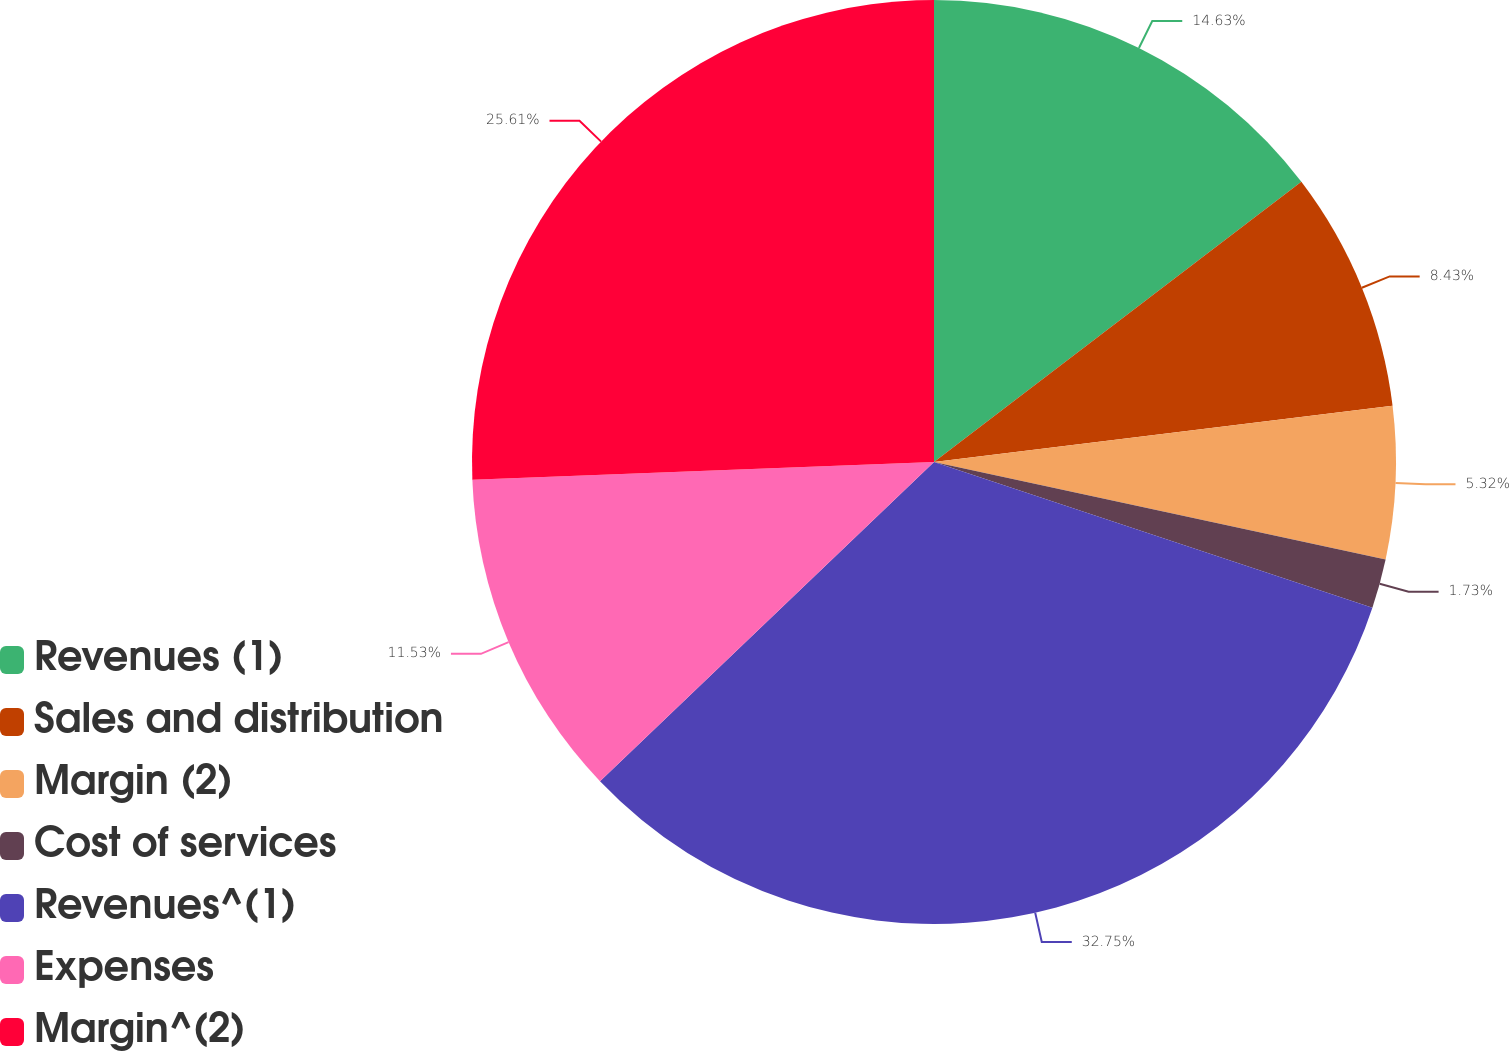Convert chart. <chart><loc_0><loc_0><loc_500><loc_500><pie_chart><fcel>Revenues (1)<fcel>Sales and distribution<fcel>Margin (2)<fcel>Cost of services<fcel>Revenues^(1)<fcel>Expenses<fcel>Margin^(2)<nl><fcel>14.63%<fcel>8.43%<fcel>5.32%<fcel>1.73%<fcel>32.75%<fcel>11.53%<fcel>25.61%<nl></chart> 